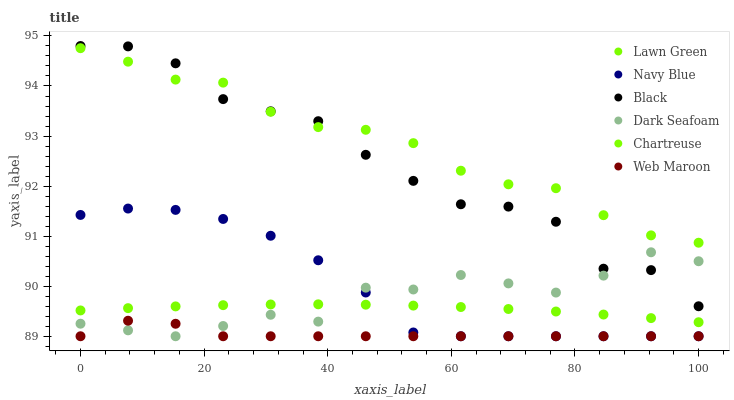Does Web Maroon have the minimum area under the curve?
Answer yes or no. Yes. Does Chartreuse have the maximum area under the curve?
Answer yes or no. Yes. Does Navy Blue have the minimum area under the curve?
Answer yes or no. No. Does Navy Blue have the maximum area under the curve?
Answer yes or no. No. Is Lawn Green the smoothest?
Answer yes or no. Yes. Is Black the roughest?
Answer yes or no. Yes. Is Navy Blue the smoothest?
Answer yes or no. No. Is Navy Blue the roughest?
Answer yes or no. No. Does Navy Blue have the lowest value?
Answer yes or no. Yes. Does Chartreuse have the lowest value?
Answer yes or no. No. Does Black have the highest value?
Answer yes or no. Yes. Does Navy Blue have the highest value?
Answer yes or no. No. Is Lawn Green less than Black?
Answer yes or no. Yes. Is Black greater than Navy Blue?
Answer yes or no. Yes. Does Dark Seafoam intersect Lawn Green?
Answer yes or no. Yes. Is Dark Seafoam less than Lawn Green?
Answer yes or no. No. Is Dark Seafoam greater than Lawn Green?
Answer yes or no. No. Does Lawn Green intersect Black?
Answer yes or no. No. 